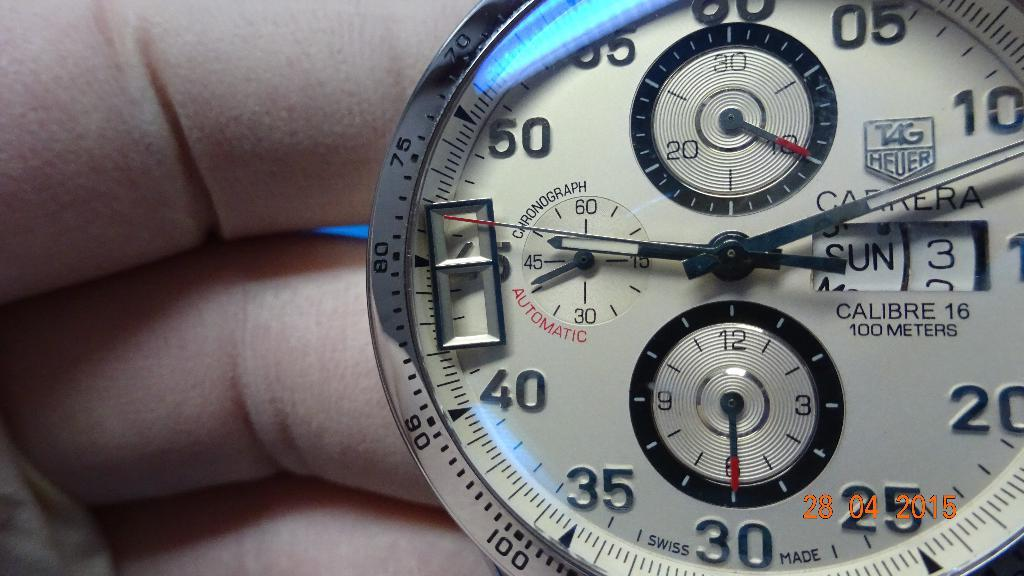Provide a one-sentence caption for the provided image. a clock with numbers on it and one that reads 40. 